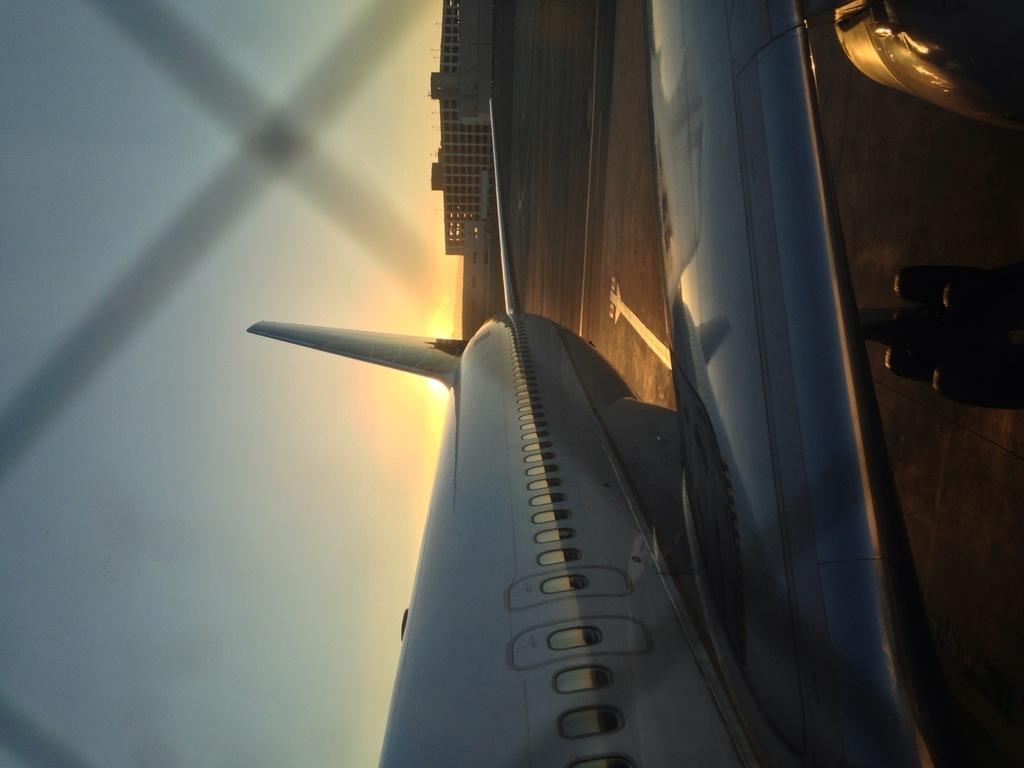What is the main subject of the image? The main subject of the image is a flight. What features can be seen on the flight? The flight has windows. What can be seen in the background of the image? Buildings and the sky are visible in the background of the image. Can you tell me how many people are swimming in the image? There is no swimming or water visible in the image; it features a flight with windows and a background of buildings and the sky. What type of punishment is being administered in the image? There is no punishment or any indication of disciplinary action in the image; it features a flight with windows and a background of buildings and the sky. 